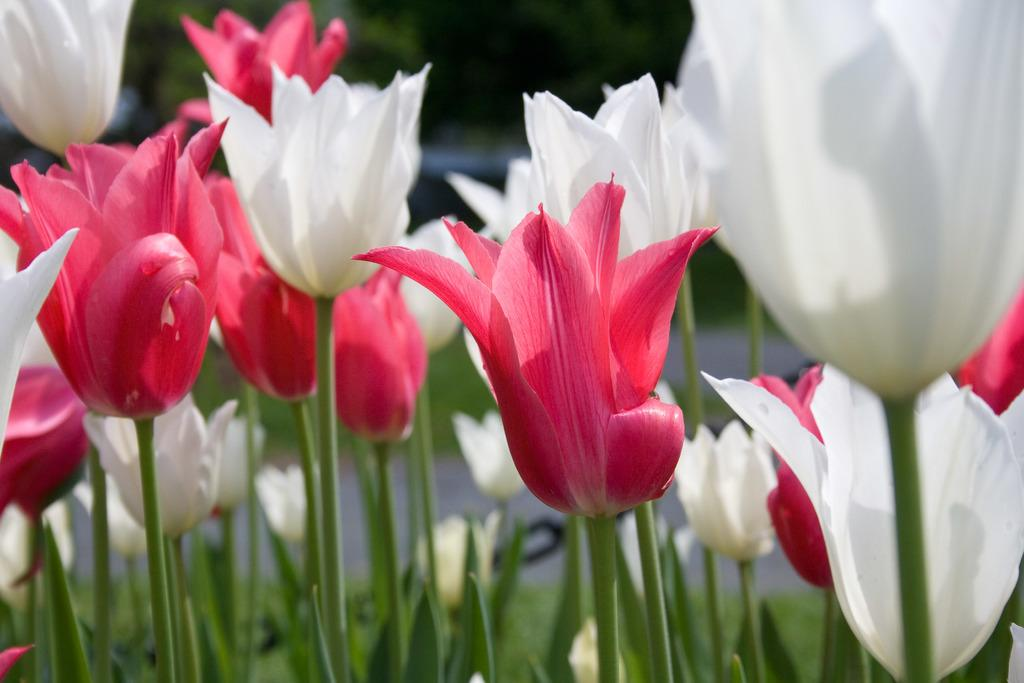What type of living organisms can be seen in the image? There are flowers and plants visible in the image. Can you describe the background of the image? The background of the image appears to be blurred. What might be the purpose of the flowers and plants in the image? The flowers and plants may be for decorative or gardening purposes. What type of brake system can be seen on the clam in the image? There is no clam or brake system present in the image. How does the fuel tank of the vehicle in the image affect the growth of the plants? There is no vehicle or fuel tank present in the image, so it cannot be determined how they might affect the growth of the plants. 